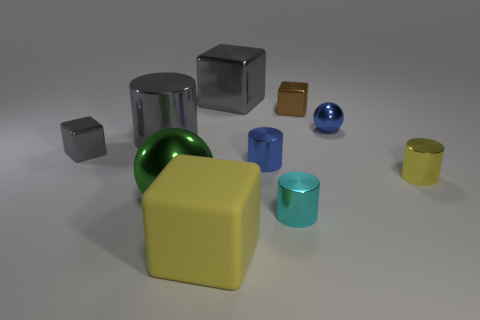Subtract 1 blocks. How many blocks are left? 3 Subtract all balls. How many objects are left? 8 Subtract 1 cyan cylinders. How many objects are left? 9 Subtract all big gray cubes. Subtract all green things. How many objects are left? 8 Add 6 large cylinders. How many large cylinders are left? 7 Add 5 big cyan cylinders. How many big cyan cylinders exist? 5 